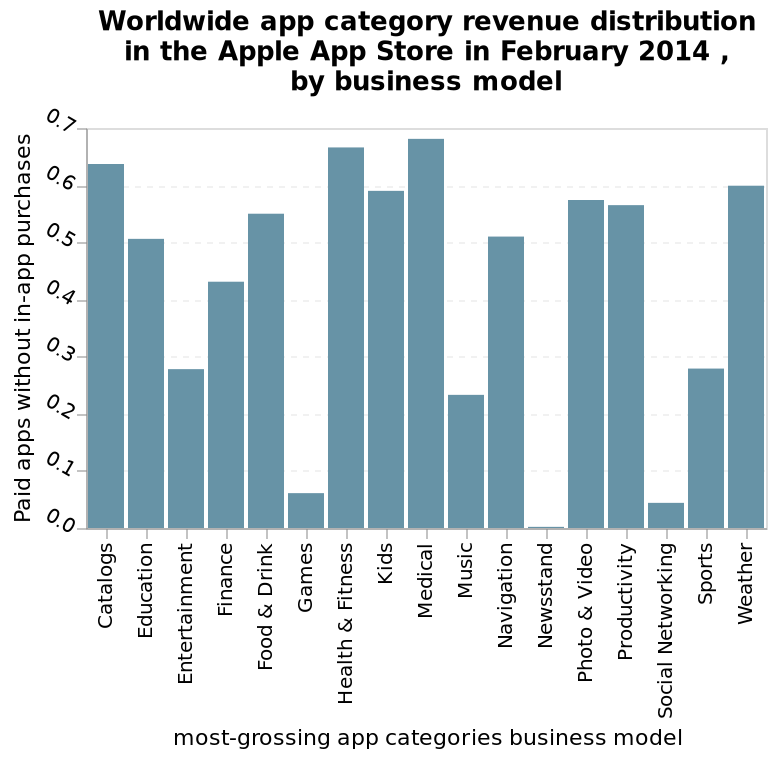<image>
In comparison to other app categories, which categories are more likely to have in-app purchases in the Apple App Store?   Games, Newsstand, and social networking sites are more likely to have in-app purchases compared to other categories of apps in the Apple App Store. What are some examples of categories of apps that are more likely to have in-app purchases in the Apple App Store?   Some examples of categories of apps that are more likely to have in-app purchases in the Apple App Store are Games, Newsstand, and social networking sites. What is the scale of the x-axis in the bar plot and what does it measure?  The scale of the x-axis in the bar plot is categorical and it measures the most-grossing app categories' business model. What is the name of the bar plot and what does it depict?  The bar plot is named "Worldwide app category revenue distribution in the Apple App Store in February 2014, by business model" and it depicts the revenue distribution of different app categories in the Apple App Store based on the business model in February 2014. 